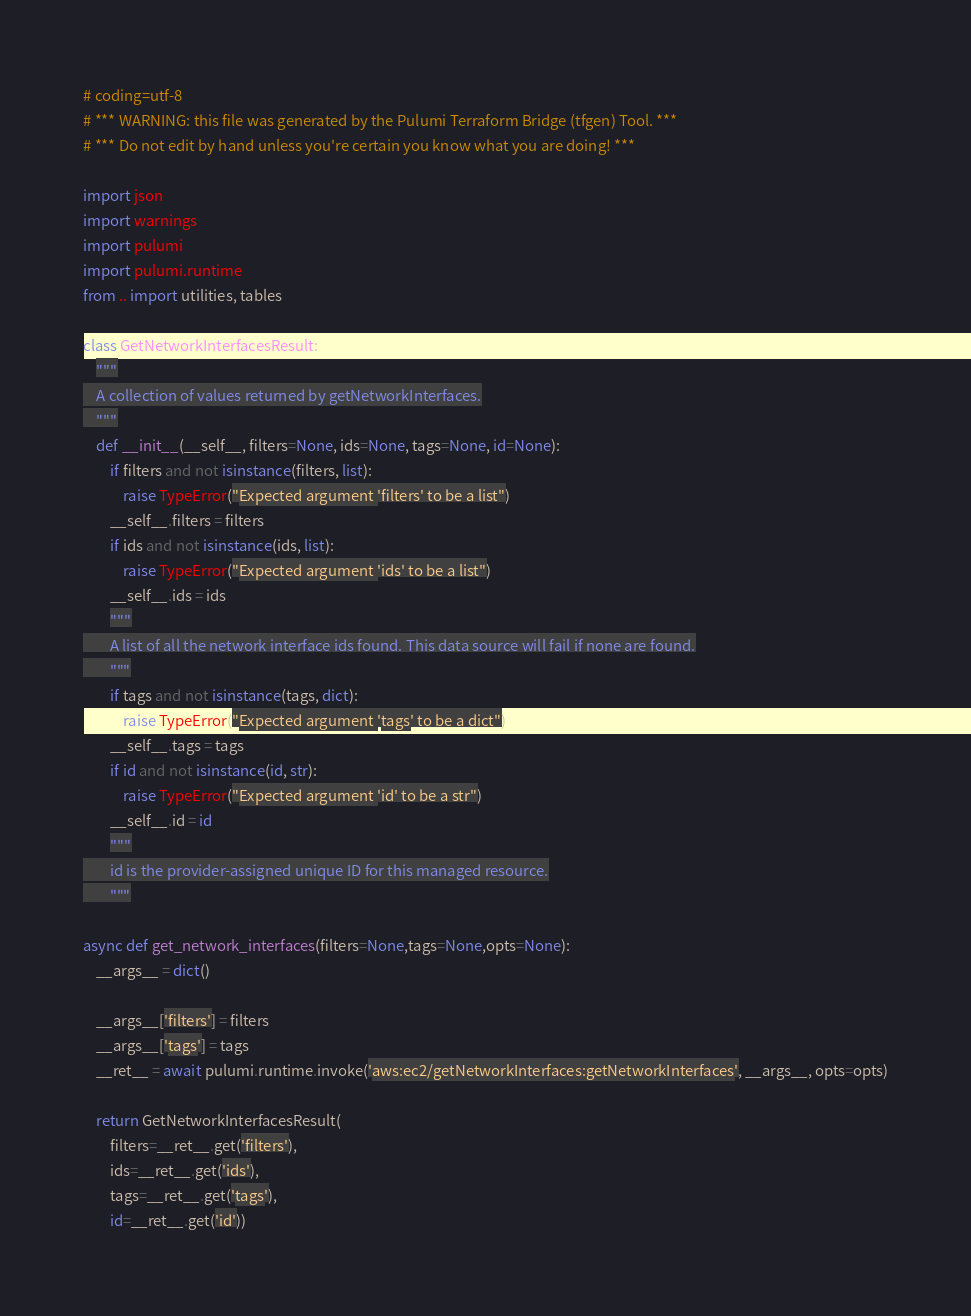<code> <loc_0><loc_0><loc_500><loc_500><_Python_># coding=utf-8
# *** WARNING: this file was generated by the Pulumi Terraform Bridge (tfgen) Tool. ***
# *** Do not edit by hand unless you're certain you know what you are doing! ***

import json
import warnings
import pulumi
import pulumi.runtime
from .. import utilities, tables

class GetNetworkInterfacesResult:
    """
    A collection of values returned by getNetworkInterfaces.
    """
    def __init__(__self__, filters=None, ids=None, tags=None, id=None):
        if filters and not isinstance(filters, list):
            raise TypeError("Expected argument 'filters' to be a list")
        __self__.filters = filters
        if ids and not isinstance(ids, list):
            raise TypeError("Expected argument 'ids' to be a list")
        __self__.ids = ids
        """
        A list of all the network interface ids found. This data source will fail if none are found.
        """
        if tags and not isinstance(tags, dict):
            raise TypeError("Expected argument 'tags' to be a dict")
        __self__.tags = tags
        if id and not isinstance(id, str):
            raise TypeError("Expected argument 'id' to be a str")
        __self__.id = id
        """
        id is the provider-assigned unique ID for this managed resource.
        """

async def get_network_interfaces(filters=None,tags=None,opts=None):
    __args__ = dict()

    __args__['filters'] = filters
    __args__['tags'] = tags
    __ret__ = await pulumi.runtime.invoke('aws:ec2/getNetworkInterfaces:getNetworkInterfaces', __args__, opts=opts)

    return GetNetworkInterfacesResult(
        filters=__ret__.get('filters'),
        ids=__ret__.get('ids'),
        tags=__ret__.get('tags'),
        id=__ret__.get('id'))
</code> 